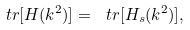<formula> <loc_0><loc_0><loc_500><loc_500>\ t r [ H ( k ^ { 2 } ) ] = \ t r [ H _ { s } ( k ^ { 2 } ) ] ,</formula> 